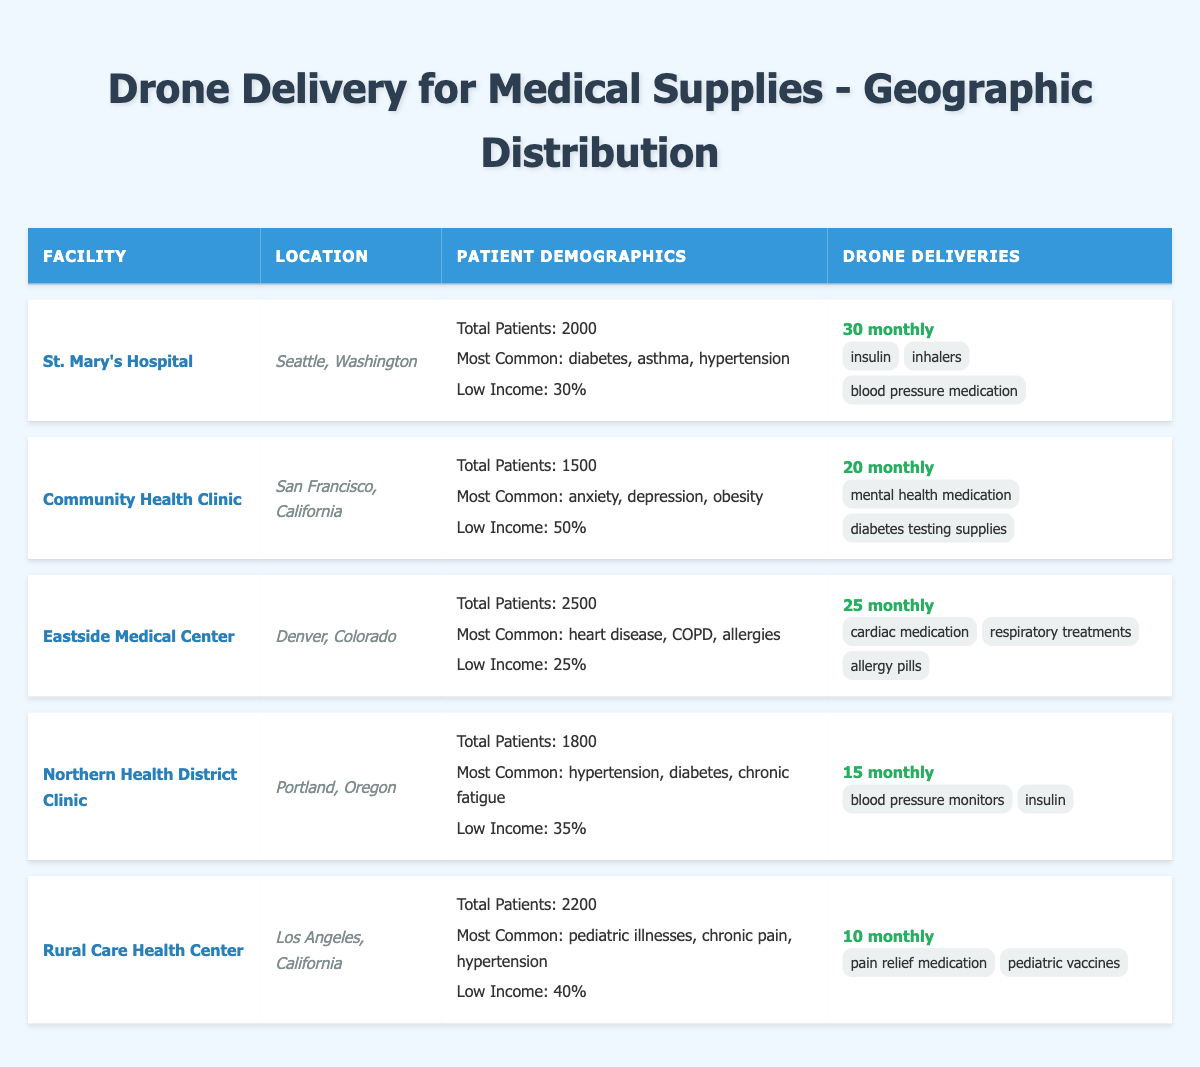What is the total number of patients across all health facilities? The total number of patients can be calculated by summing the total patients from each facility: (2000 + 1500 + 2500 + 1800 + 2200) = 11000.
Answer: 11000 Which facility has the highest percentage of low-income patients? By examining the low-income percentages in each facility, Community Health Clinic has the highest at 50%.
Answer: Community Health Clinic How many types of medical items are delivered monthly at Eastside Medical Center? Eastside Medical Center has three types of items delivered: cardiac medication, respiratory treatments, and allergy pills.
Answer: 3 What is the average monthly delivery of medical supplies across all health facilities? The monthly deliveries are: 30 (St. Mary's) + 20 (Community Health Clinic) + 25 (Eastside Medical Center) + 15 (Northern Health District Clinic) + 10 (Rural Care Health Center) = 100 total deliveries. There are 5 facilities, so the average is 100 / 5 = 20.
Answer: 20 Is there a facility that delivers pediatric vaccines? Yes, Rural Care Health Center delivers pediatric vaccines.
Answer: Yes What percentage of patients at St. Mary's Hospital are aged 35 and above? St. Mary's Hospital has 400 patients aged 35-64 and 200 patients aged 65+, totaling 600 patients aged 35 and above. To find the percentage: (600 / 2000) * 100 = 30%.
Answer: 30% Which facility, between Northern Health District Clinic and Rural Care Health Center, has more total patients? Northern Health District Clinic has 1800 total patients while Rural Care Health Center has 2200. Thus, Rural Care Health Center has more patients.
Answer: Rural Care Health Center Identify the most common condition among the patients of Eastside Medical Center. The most common condition listed for Eastside Medical Center is heart disease.
Answer: Heart disease What is the combined total of the age group 0-18 across all facilities? The total number of patients aged 0-18 is: (600 + 300 + 500 + 400 + 500) = 2300 across all facilities.
Answer: 2300 Which city has a health facility with the lowest monthly deliveries? The facility with the lowest monthly deliveries is Rural Care Health Center in Los Angeles, with 10 deliveries.
Answer: Los Angeles 